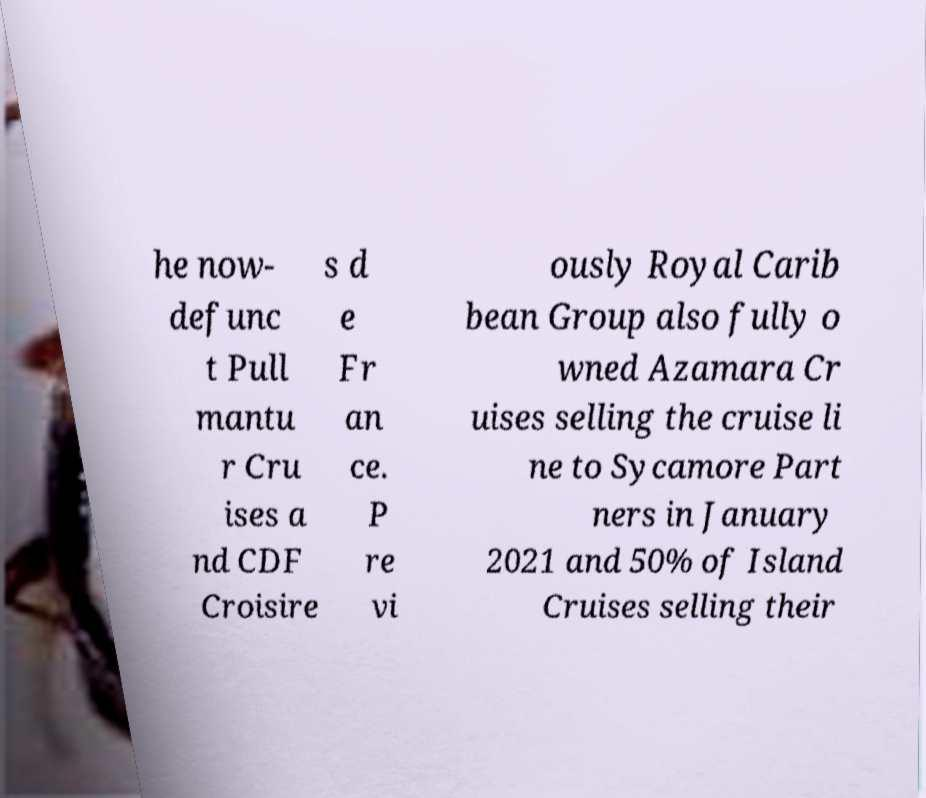For documentation purposes, I need the text within this image transcribed. Could you provide that? he now- defunc t Pull mantu r Cru ises a nd CDF Croisire s d e Fr an ce. P re vi ously Royal Carib bean Group also fully o wned Azamara Cr uises selling the cruise li ne to Sycamore Part ners in January 2021 and 50% of Island Cruises selling their 